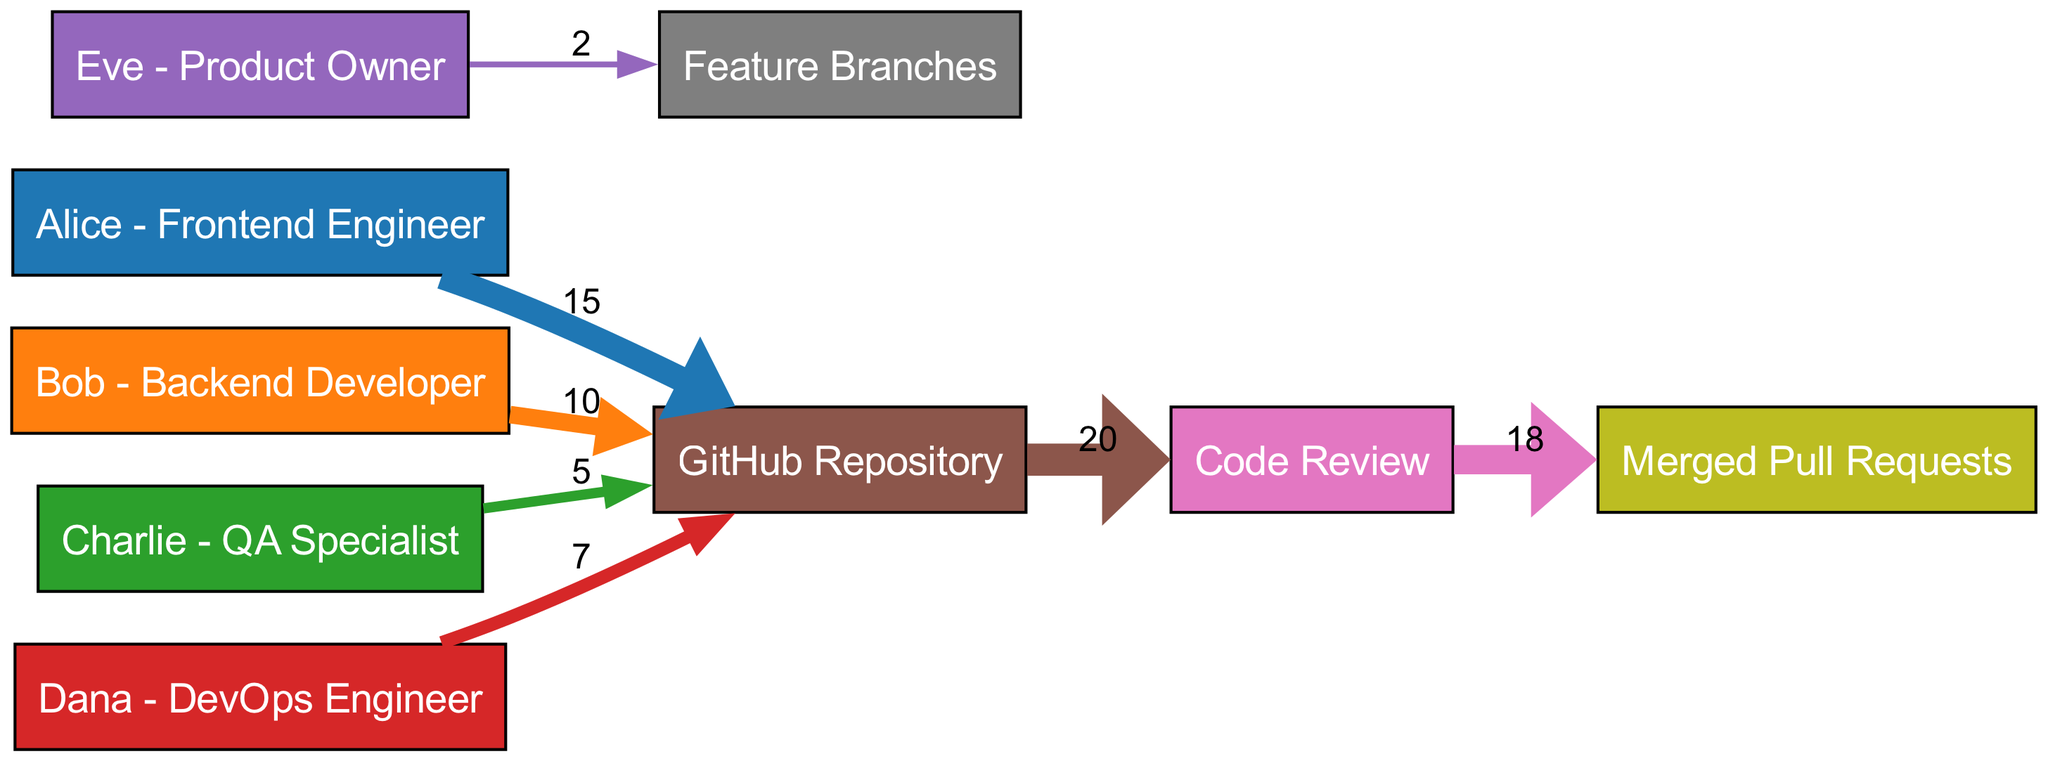What is the total number of nodes in the diagram? The diagram lists all the distinct entities involved in the process, which include the contributors and various stages of the workflow. By counting each unique node provided in the data, we find there are nine nodes in total.
Answer: 9 How many contributions did Alice make to the GitHub Repository? By examining the link data, we see that the specific connection from Alice to the GitHub Repository shows a value of 15, indicating the number of contributions she made.
Answer: 15 What is the value of links from the GitHub Repository to Code Review? Looking at the flow from the GitHub Repository to Code Review, the link data indicates a value of 20, representing the total contributions that entered the Code Review stage from the repository.
Answer: 20 Which team member contributed the least number of code contributions? By comparing the values associated with each team member's contributions to the GitHub Repository, it is evident that Charlie has the lowest count, with a value of 5.
Answer: Charlie What is the total number of merged pull requests? The link from Code Review to Merged Pull Requests has a value of 18, which indicates the total number of pull requests that were successfully merged after reviewing the contributions.
Answer: 18 How many contributions did Dana make to the GitHub Repository compared to Bob? Dana contributed 7 to the GitHub Repository and Bob contributed 10, which means that Bob made 3 more contributions than Dana. This comparison reveals that Bob had a higher contribution count.
Answer: 3 more What percentage of contributions to the GitHub Repository came from Alice? Total contributions to the GitHub Repository add up to 37 (15 from Alice, 10 from Bob, 5 from Charlie, and 7 from Dana). Alice's contributions make up 15 out of 37, which gives us approximately 40.54 percent of total contributions from her.
Answer: 40.54 percent How many links are there from the GitHub Repository? The diagram shows that there are three distinct outgoing links from the GitHub Repository: to Code Review and two internal links to Feature Branches and Merged Pull Requests, resulting in a total of two outgoing links.
Answer: 2 What is the total contribution value of all team members combined to the GitHub Repository? By summing the contribution values from all team members: 15 (Alice) + 10 (Bob) + 5 (Charlie) + 7 (Dana), we get a total contribution value of 37 to the GitHub Repository.
Answer: 37 